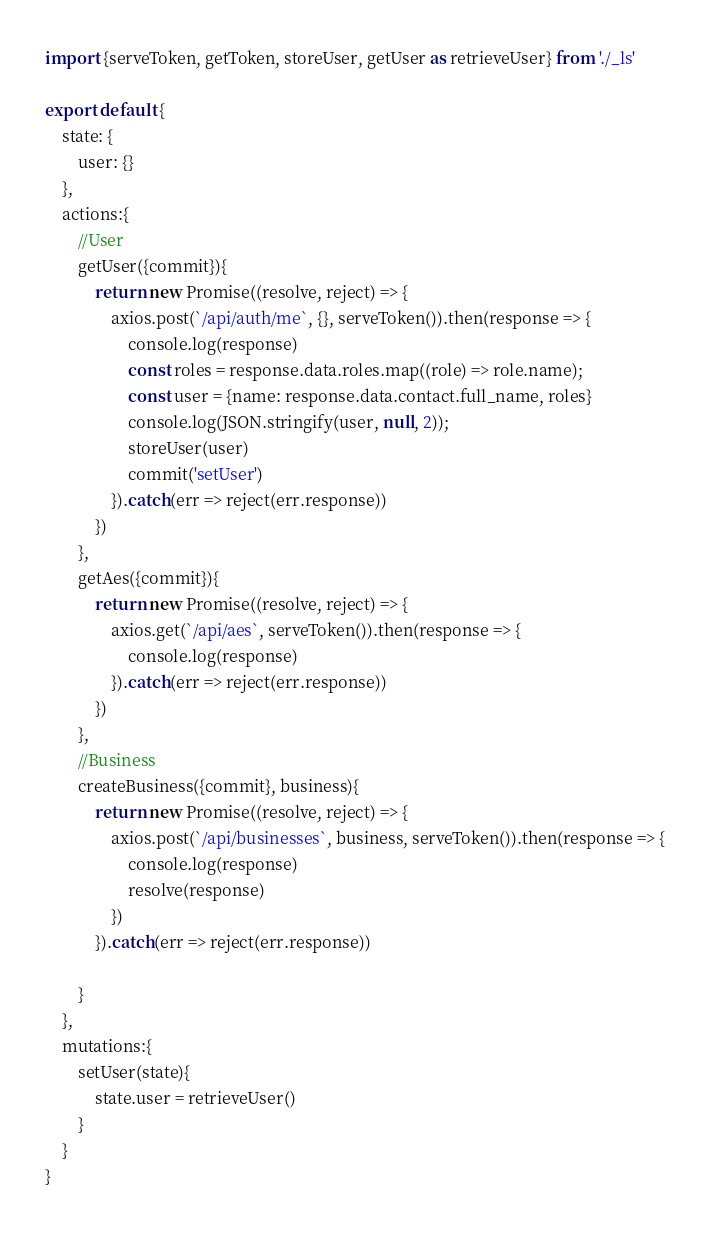<code> <loc_0><loc_0><loc_500><loc_500><_JavaScript_>import {serveToken, getToken, storeUser, getUser as retrieveUser} from './_ls'

export default {
    state: {
        user: {}
    },
    actions:{
        //User
        getUser({commit}){
            return new Promise((resolve, reject) => {
                axios.post(`/api/auth/me`, {}, serveToken()).then(response => {
                    console.log(response)
                    const roles = response.data.roles.map((role) => role.name);
                    const user = {name: response.data.contact.full_name, roles}
                    console.log(JSON.stringify(user, null, 2));
                    storeUser(user)
                    commit('setUser')
                }).catch(err => reject(err.response))
            })
        },
        getAes({commit}){
            return new Promise((resolve, reject) => {
                axios.get(`/api/aes`, serveToken()).then(response => {
                    console.log(response)
                }).catch(err => reject(err.response))
            })
        },
        //Business
        createBusiness({commit}, business){
            return new Promise((resolve, reject) => {
                axios.post(`/api/businesses`, business, serveToken()).then(response => {
                    console.log(response)
                    resolve(response)
                })
            }).catch(err => reject(err.response))
            
        }
    },
    mutations:{
        setUser(state){
            state.user = retrieveUser()
        }
    }
}</code> 